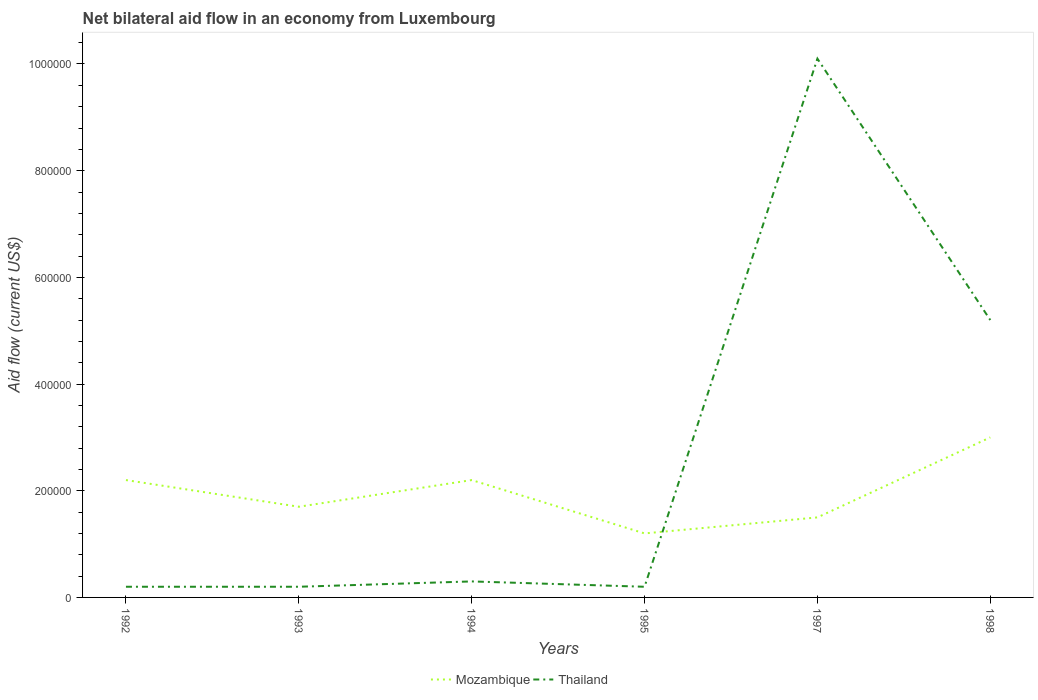How many different coloured lines are there?
Make the answer very short. 2. What is the difference between the highest and the second highest net bilateral aid flow in Mozambique?
Keep it short and to the point. 1.80e+05. What is the difference between the highest and the lowest net bilateral aid flow in Mozambique?
Your answer should be very brief. 3. How many lines are there?
Offer a terse response. 2. How many years are there in the graph?
Your answer should be compact. 6. What is the difference between two consecutive major ticks on the Y-axis?
Offer a terse response. 2.00e+05. Does the graph contain any zero values?
Keep it short and to the point. No. Where does the legend appear in the graph?
Your response must be concise. Bottom center. How are the legend labels stacked?
Provide a succinct answer. Horizontal. What is the title of the graph?
Keep it short and to the point. Net bilateral aid flow in an economy from Luxembourg. What is the label or title of the X-axis?
Offer a very short reply. Years. What is the Aid flow (current US$) of Thailand in 1992?
Your answer should be very brief. 2.00e+04. What is the Aid flow (current US$) in Mozambique in 1994?
Ensure brevity in your answer.  2.20e+05. What is the Aid flow (current US$) in Thailand in 1994?
Offer a very short reply. 3.00e+04. What is the Aid flow (current US$) of Mozambique in 1995?
Your answer should be compact. 1.20e+05. What is the Aid flow (current US$) of Mozambique in 1997?
Provide a short and direct response. 1.50e+05. What is the Aid flow (current US$) of Thailand in 1997?
Offer a terse response. 1.01e+06. What is the Aid flow (current US$) of Mozambique in 1998?
Make the answer very short. 3.00e+05. What is the Aid flow (current US$) of Thailand in 1998?
Give a very brief answer. 5.20e+05. Across all years, what is the maximum Aid flow (current US$) in Thailand?
Offer a terse response. 1.01e+06. Across all years, what is the minimum Aid flow (current US$) in Mozambique?
Keep it short and to the point. 1.20e+05. What is the total Aid flow (current US$) of Mozambique in the graph?
Your answer should be compact. 1.18e+06. What is the total Aid flow (current US$) in Thailand in the graph?
Keep it short and to the point. 1.62e+06. What is the difference between the Aid flow (current US$) of Thailand in 1992 and that in 1993?
Provide a succinct answer. 0. What is the difference between the Aid flow (current US$) in Mozambique in 1992 and that in 1994?
Your response must be concise. 0. What is the difference between the Aid flow (current US$) of Thailand in 1992 and that in 1994?
Offer a terse response. -10000. What is the difference between the Aid flow (current US$) of Mozambique in 1992 and that in 1995?
Offer a terse response. 1.00e+05. What is the difference between the Aid flow (current US$) of Thailand in 1992 and that in 1995?
Your answer should be very brief. 0. What is the difference between the Aid flow (current US$) of Thailand in 1992 and that in 1997?
Your answer should be very brief. -9.90e+05. What is the difference between the Aid flow (current US$) in Mozambique in 1992 and that in 1998?
Make the answer very short. -8.00e+04. What is the difference between the Aid flow (current US$) of Thailand in 1992 and that in 1998?
Your answer should be very brief. -5.00e+05. What is the difference between the Aid flow (current US$) in Mozambique in 1993 and that in 1994?
Provide a short and direct response. -5.00e+04. What is the difference between the Aid flow (current US$) in Thailand in 1993 and that in 1997?
Your response must be concise. -9.90e+05. What is the difference between the Aid flow (current US$) in Mozambique in 1993 and that in 1998?
Your answer should be compact. -1.30e+05. What is the difference between the Aid flow (current US$) in Thailand in 1993 and that in 1998?
Offer a terse response. -5.00e+05. What is the difference between the Aid flow (current US$) of Mozambique in 1994 and that in 1995?
Give a very brief answer. 1.00e+05. What is the difference between the Aid flow (current US$) in Thailand in 1994 and that in 1997?
Keep it short and to the point. -9.80e+05. What is the difference between the Aid flow (current US$) in Mozambique in 1994 and that in 1998?
Offer a terse response. -8.00e+04. What is the difference between the Aid flow (current US$) in Thailand in 1994 and that in 1998?
Keep it short and to the point. -4.90e+05. What is the difference between the Aid flow (current US$) of Mozambique in 1995 and that in 1997?
Provide a short and direct response. -3.00e+04. What is the difference between the Aid flow (current US$) of Thailand in 1995 and that in 1997?
Your answer should be compact. -9.90e+05. What is the difference between the Aid flow (current US$) in Mozambique in 1995 and that in 1998?
Provide a short and direct response. -1.80e+05. What is the difference between the Aid flow (current US$) of Thailand in 1995 and that in 1998?
Offer a very short reply. -5.00e+05. What is the difference between the Aid flow (current US$) in Mozambique in 1992 and the Aid flow (current US$) in Thailand in 1997?
Keep it short and to the point. -7.90e+05. What is the difference between the Aid flow (current US$) of Mozambique in 1993 and the Aid flow (current US$) of Thailand in 1997?
Offer a very short reply. -8.40e+05. What is the difference between the Aid flow (current US$) of Mozambique in 1993 and the Aid flow (current US$) of Thailand in 1998?
Offer a very short reply. -3.50e+05. What is the difference between the Aid flow (current US$) in Mozambique in 1994 and the Aid flow (current US$) in Thailand in 1997?
Keep it short and to the point. -7.90e+05. What is the difference between the Aid flow (current US$) of Mozambique in 1994 and the Aid flow (current US$) of Thailand in 1998?
Offer a terse response. -3.00e+05. What is the difference between the Aid flow (current US$) in Mozambique in 1995 and the Aid flow (current US$) in Thailand in 1997?
Keep it short and to the point. -8.90e+05. What is the difference between the Aid flow (current US$) in Mozambique in 1995 and the Aid flow (current US$) in Thailand in 1998?
Ensure brevity in your answer.  -4.00e+05. What is the difference between the Aid flow (current US$) in Mozambique in 1997 and the Aid flow (current US$) in Thailand in 1998?
Your answer should be very brief. -3.70e+05. What is the average Aid flow (current US$) of Mozambique per year?
Your answer should be very brief. 1.97e+05. In the year 1997, what is the difference between the Aid flow (current US$) of Mozambique and Aid flow (current US$) of Thailand?
Provide a short and direct response. -8.60e+05. What is the ratio of the Aid flow (current US$) of Mozambique in 1992 to that in 1993?
Make the answer very short. 1.29. What is the ratio of the Aid flow (current US$) of Thailand in 1992 to that in 1993?
Offer a very short reply. 1. What is the ratio of the Aid flow (current US$) of Mozambique in 1992 to that in 1994?
Give a very brief answer. 1. What is the ratio of the Aid flow (current US$) in Mozambique in 1992 to that in 1995?
Ensure brevity in your answer.  1.83. What is the ratio of the Aid flow (current US$) of Thailand in 1992 to that in 1995?
Keep it short and to the point. 1. What is the ratio of the Aid flow (current US$) in Mozambique in 1992 to that in 1997?
Offer a terse response. 1.47. What is the ratio of the Aid flow (current US$) in Thailand in 1992 to that in 1997?
Ensure brevity in your answer.  0.02. What is the ratio of the Aid flow (current US$) of Mozambique in 1992 to that in 1998?
Your answer should be very brief. 0.73. What is the ratio of the Aid flow (current US$) in Thailand in 1992 to that in 1998?
Give a very brief answer. 0.04. What is the ratio of the Aid flow (current US$) in Mozambique in 1993 to that in 1994?
Your answer should be very brief. 0.77. What is the ratio of the Aid flow (current US$) in Mozambique in 1993 to that in 1995?
Give a very brief answer. 1.42. What is the ratio of the Aid flow (current US$) of Thailand in 1993 to that in 1995?
Provide a short and direct response. 1. What is the ratio of the Aid flow (current US$) of Mozambique in 1993 to that in 1997?
Give a very brief answer. 1.13. What is the ratio of the Aid flow (current US$) of Thailand in 1993 to that in 1997?
Offer a very short reply. 0.02. What is the ratio of the Aid flow (current US$) in Mozambique in 1993 to that in 1998?
Give a very brief answer. 0.57. What is the ratio of the Aid flow (current US$) in Thailand in 1993 to that in 1998?
Offer a very short reply. 0.04. What is the ratio of the Aid flow (current US$) of Mozambique in 1994 to that in 1995?
Your response must be concise. 1.83. What is the ratio of the Aid flow (current US$) of Thailand in 1994 to that in 1995?
Your answer should be very brief. 1.5. What is the ratio of the Aid flow (current US$) in Mozambique in 1994 to that in 1997?
Offer a very short reply. 1.47. What is the ratio of the Aid flow (current US$) of Thailand in 1994 to that in 1997?
Ensure brevity in your answer.  0.03. What is the ratio of the Aid flow (current US$) of Mozambique in 1994 to that in 1998?
Offer a very short reply. 0.73. What is the ratio of the Aid flow (current US$) in Thailand in 1994 to that in 1998?
Offer a very short reply. 0.06. What is the ratio of the Aid flow (current US$) of Mozambique in 1995 to that in 1997?
Ensure brevity in your answer.  0.8. What is the ratio of the Aid flow (current US$) of Thailand in 1995 to that in 1997?
Offer a very short reply. 0.02. What is the ratio of the Aid flow (current US$) of Mozambique in 1995 to that in 1998?
Give a very brief answer. 0.4. What is the ratio of the Aid flow (current US$) of Thailand in 1995 to that in 1998?
Keep it short and to the point. 0.04. What is the ratio of the Aid flow (current US$) in Thailand in 1997 to that in 1998?
Keep it short and to the point. 1.94. What is the difference between the highest and the second highest Aid flow (current US$) in Thailand?
Your answer should be very brief. 4.90e+05. What is the difference between the highest and the lowest Aid flow (current US$) of Thailand?
Keep it short and to the point. 9.90e+05. 